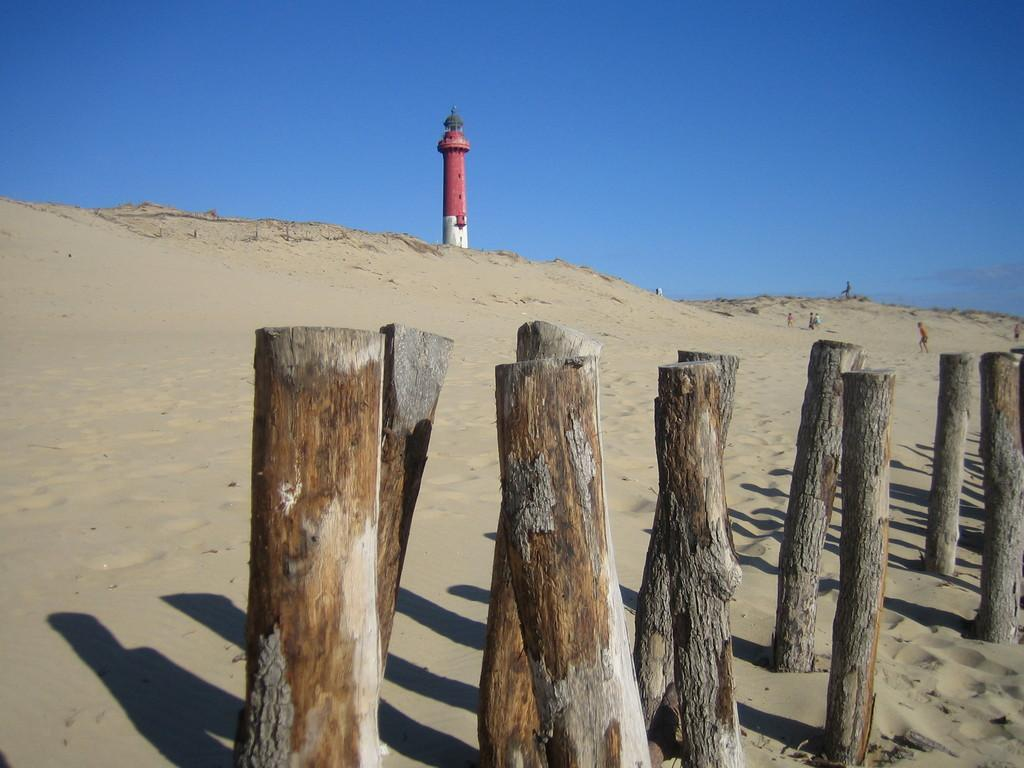What is placed in the sand in the image? There are bamboos placed in the sand. What can be seen in the background of the image? There is a red color lighthouse in the background. What are the boys doing on the right side of the image? The boys are playing in the sand on the right side of the image. What type of test is the boy conducting in the image? There is no test or boy conducting a test present in the image. What is the quill used for in the image? There is no quill present in the image. 